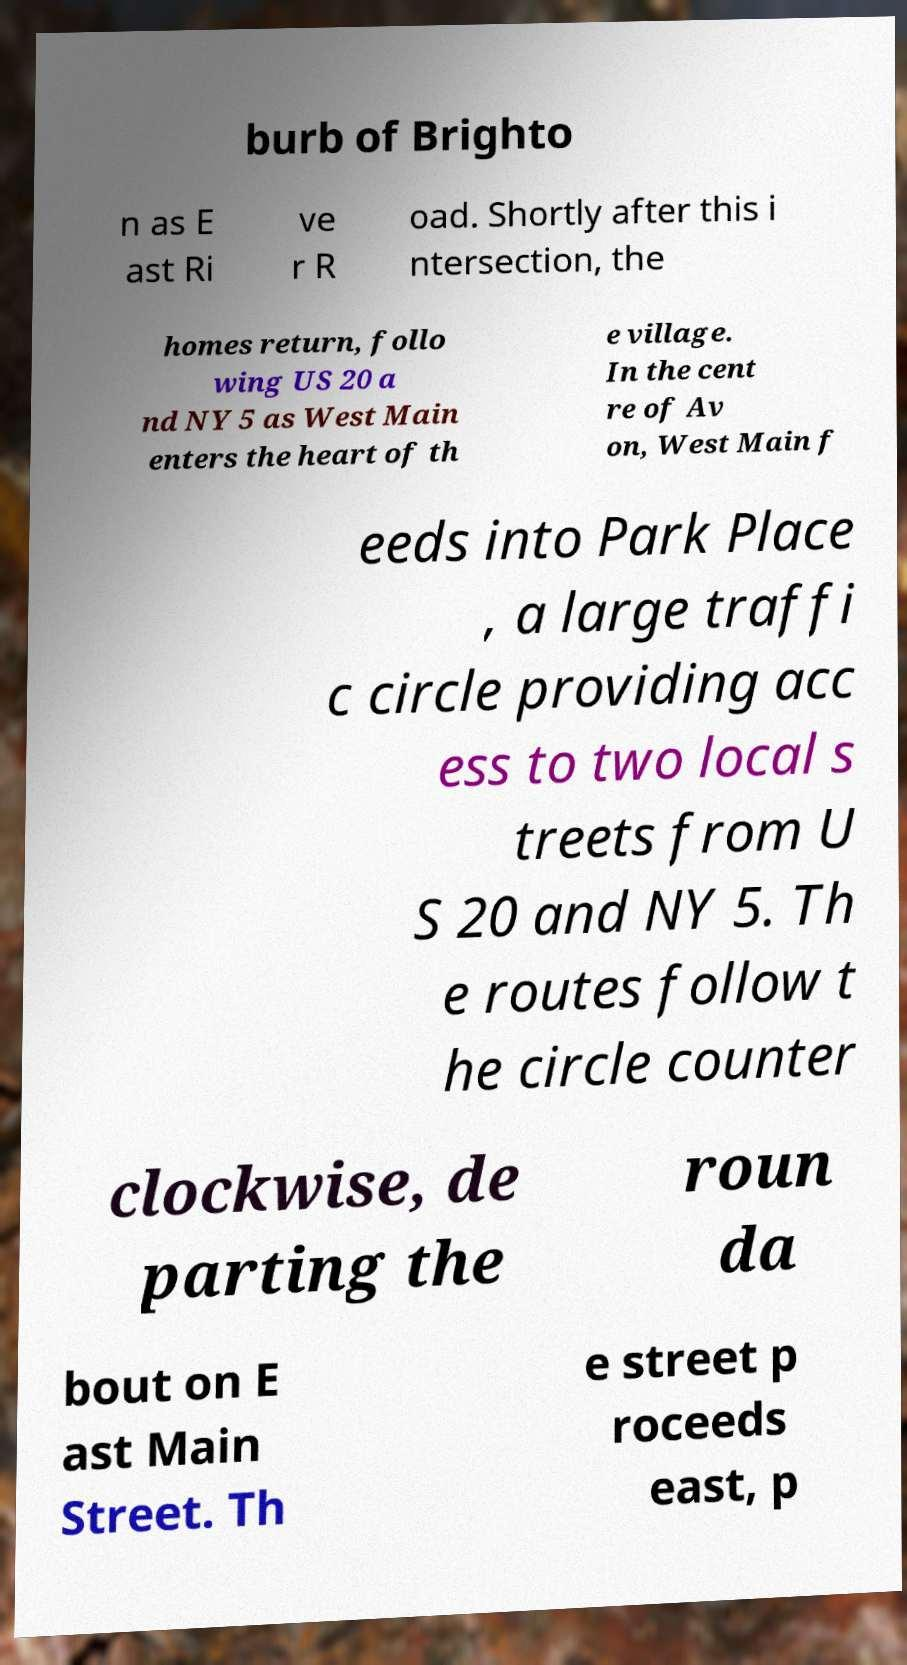There's text embedded in this image that I need extracted. Can you transcribe it verbatim? burb of Brighto n as E ast Ri ve r R oad. Shortly after this i ntersection, the homes return, follo wing US 20 a nd NY 5 as West Main enters the heart of th e village. In the cent re of Av on, West Main f eeds into Park Place , a large traffi c circle providing acc ess to two local s treets from U S 20 and NY 5. Th e routes follow t he circle counter clockwise, de parting the roun da bout on E ast Main Street. Th e street p roceeds east, p 